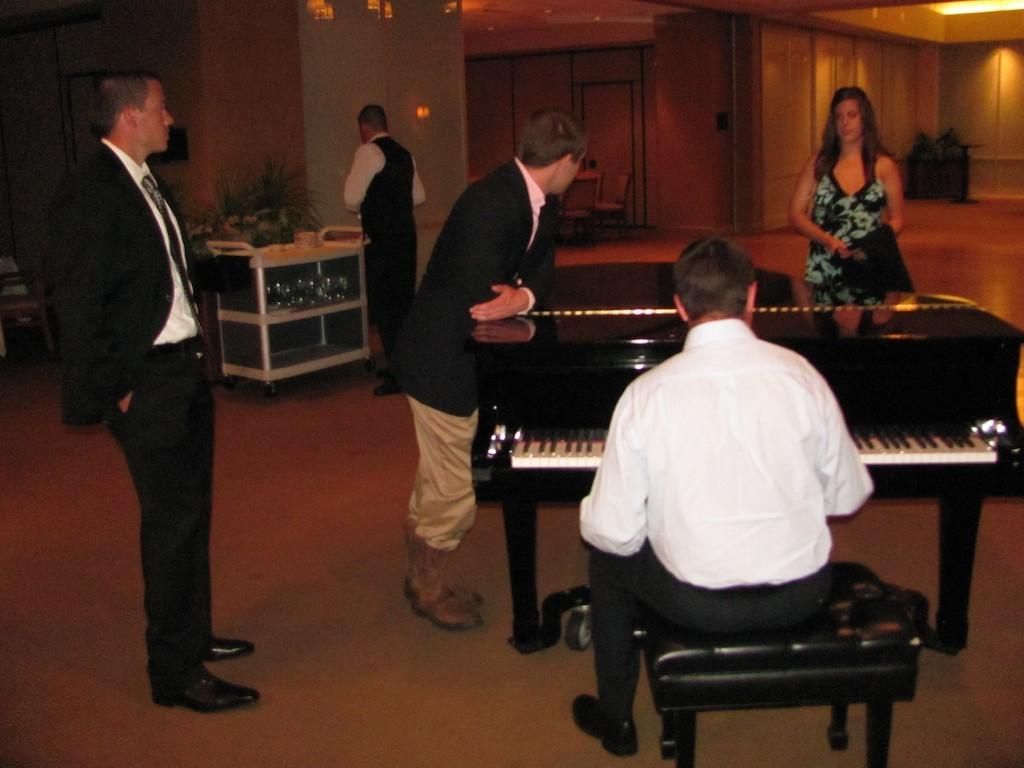How many people are in the image? There are four people standing in the image, and one person is sitting. What is the person who is sitting doing? The person who is sitting is playing a piano. How many cars can be seen in the image? There are no cars visible in the image. Is the queen present in the image? There is no mention of a queen or any royal figure in the image. 